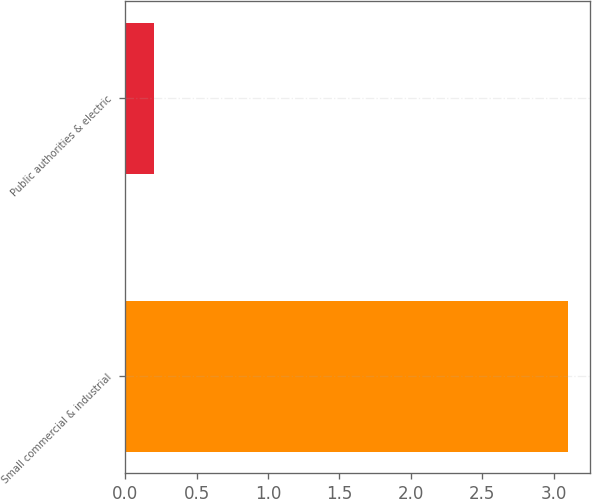<chart> <loc_0><loc_0><loc_500><loc_500><bar_chart><fcel>Small commercial & industrial<fcel>Public authorities & electric<nl><fcel>3.1<fcel>0.2<nl></chart> 